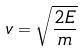<formula> <loc_0><loc_0><loc_500><loc_500>v = \sqrt { \frac { 2 E } { m } }</formula> 